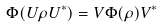<formula> <loc_0><loc_0><loc_500><loc_500>\Phi ( U \rho U ^ { \ast } ) = V \Phi ( \rho ) V ^ { \ast }</formula> 